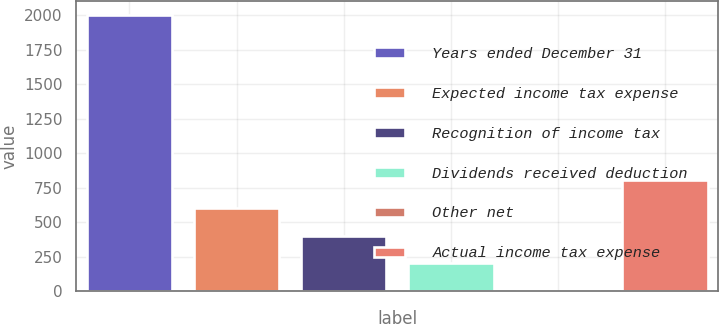<chart> <loc_0><loc_0><loc_500><loc_500><bar_chart><fcel>Years ended December 31<fcel>Expected income tax expense<fcel>Recognition of income tax<fcel>Dividends received deduction<fcel>Other net<fcel>Actual income tax expense<nl><fcel>2004<fcel>601.27<fcel>400.88<fcel>200.49<fcel>0.1<fcel>801.66<nl></chart> 